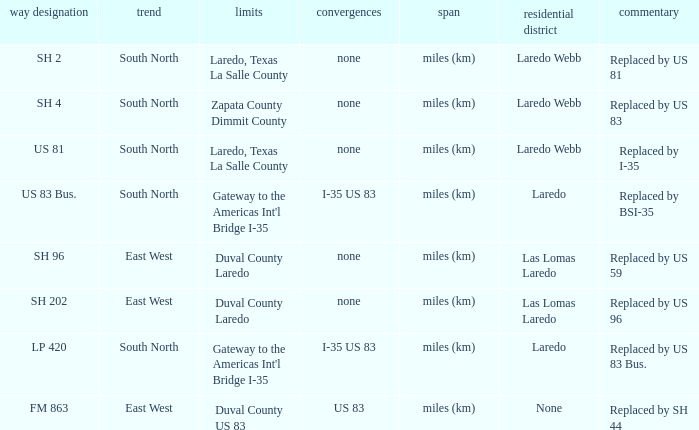What unit of length is being used for the route with "replaced by us 81" in their remarks section? Miles (km). 